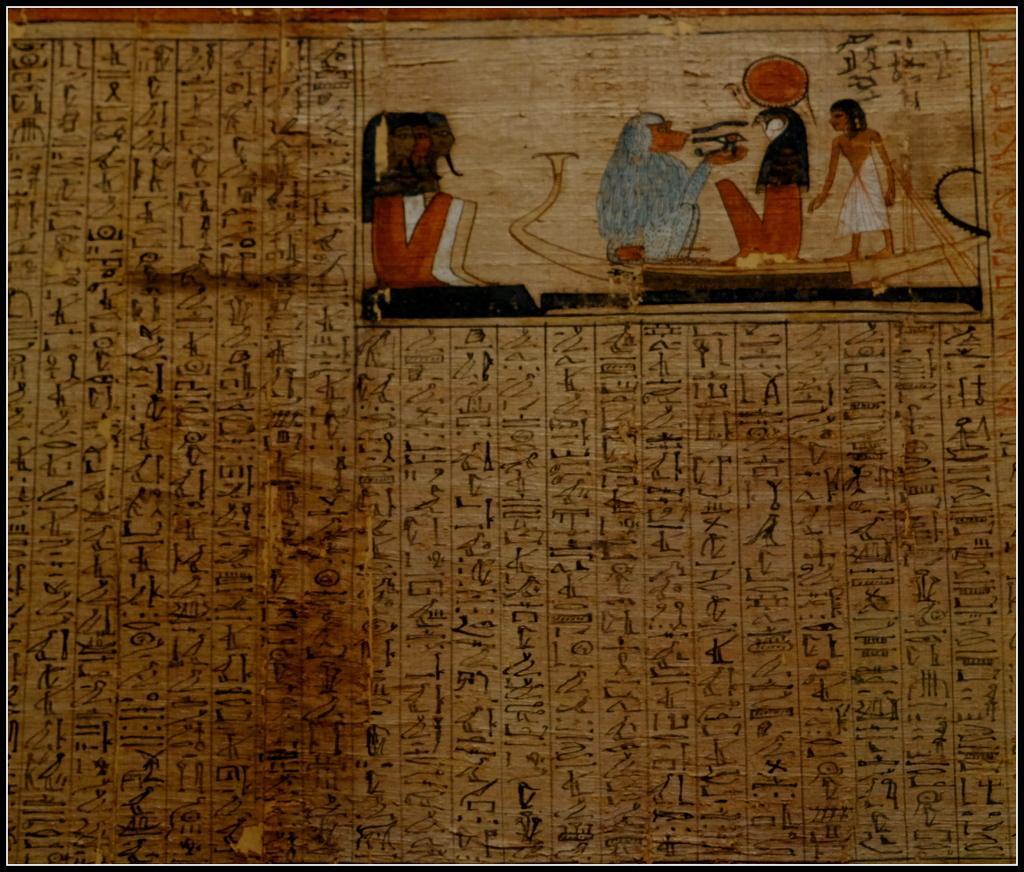How would you summarize this image in a sentence or two? This is a painting. In this image there is a painting of a person and there is a painting of a monkey and there is a text. 